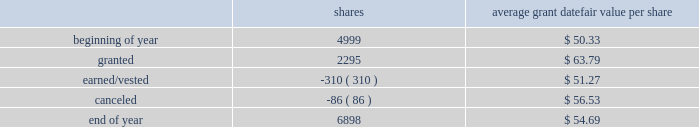2018 emerson annual report | 51 as of september 30 , 2018 , 1874750 shares awarded primarily in 2016 were outstanding , contingent on the company achieving its performance objectives through 2018 .
The objectives for these shares were met at the 97 percent level at the end of 2018 and 1818508 shares will be distributed in early 2019 .
Additionally , the rights to receive a maximum of 2261700 and 2375313 common shares were awarded in 2018 and 2017 , respectively , under the new performance shares program , and are outstanding and contingent upon the company achieving its performance objectives through 2020 and 2019 , respectively .
Incentive shares plans also include restricted stock awards which involve distribution of common stock to key management employees subject to cliff vesting at the end of service periods ranging from three to ten years .
The fair value of restricted stock awards is determined based on the average of the high and low market prices of the company 2019s common stock on the date of grant , with compensation expense recognized ratably over the applicable service period .
In 2018 , 310000 shares of restricted stock vested as a result of participants fulfilling the applicable service requirements .
Consequently , 167837 shares were issued while 142163 shares were withheld for income taxes in accordance with minimum withholding requirements .
As of september 30 , 2018 , there were 1276200 shares of unvested restricted stock outstanding .
The total fair value of shares distributed under incentive shares plans was $ 20 , $ 245 and $ 11 , respectively , in 2018 , 2017 and 2016 , of which $ 9 , $ 101 and $ 4 was paid in cash , primarily for tax withholding .
As of september 30 , 2018 , 10.3 million shares remained available for award under incentive shares plans .
Changes in shares outstanding but not yet earned under incentive shares plans during the year ended september 30 , 2018 follow ( shares in thousands ; assumes 100 percent payout of unvested awards ) : average grant date shares fair value per share .
Total compensation expense for stock options and incentive shares was $ 216 , $ 115 and $ 159 for 2018 , 2017 and 2016 , respectively , of which $ 5 and $ 14 was included in discontinued operations for 2017 and 2016 , respectively .
The increase in expense for 2018 reflects an increase in the company 2019s stock price and progress toward achieving its performance objectives .
The decrease in expense for 2017 reflects the impact of changes in the stock price .
Income tax benefits recognized in the income statement for these compensation arrangements during 2018 , 2017 and 2016 were $ 42 , $ 33 and $ 45 , respectively .
As of september 30 , 2018 , total unrecognized compensation expense related to unvested shares awarded under these plans was $ 182 , which is expected to be recognized over a weighted-average period of 1.1 years .
In addition to the employee stock option and incentive shares plans , in 2018 the company awarded 12228 shares of restricted stock and 2038 restricted stock units under the restricted stock plan for non-management directors .
As of september 30 , 2018 , 159965 shares were available for issuance under this plan .
( 16 ) common and preferred stock at september 30 , 2018 , 37.0 million shares of common stock were reserved for issuance under the company 2019s stock-based compensation plans .
During 2018 , 15.1 million common shares were purchased and 2.6 million treasury shares were reissued .
In 2017 , 6.6 million common shares were purchased and 5.5 million treasury shares were reissued .
At september 30 , 2018 and 2017 , the company had 5.4 million shares of $ 2.50 par value preferred stock authorized , with none issued. .
What was the percent change in average grant datefair value per share from the beginning of the year to the end of the year? 
Computations: ((54.69 - 50.33) / 50.33)
Answer: 0.08663. 